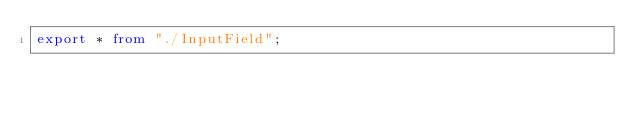Convert code to text. <code><loc_0><loc_0><loc_500><loc_500><_TypeScript_>export * from "./InputField";
</code> 